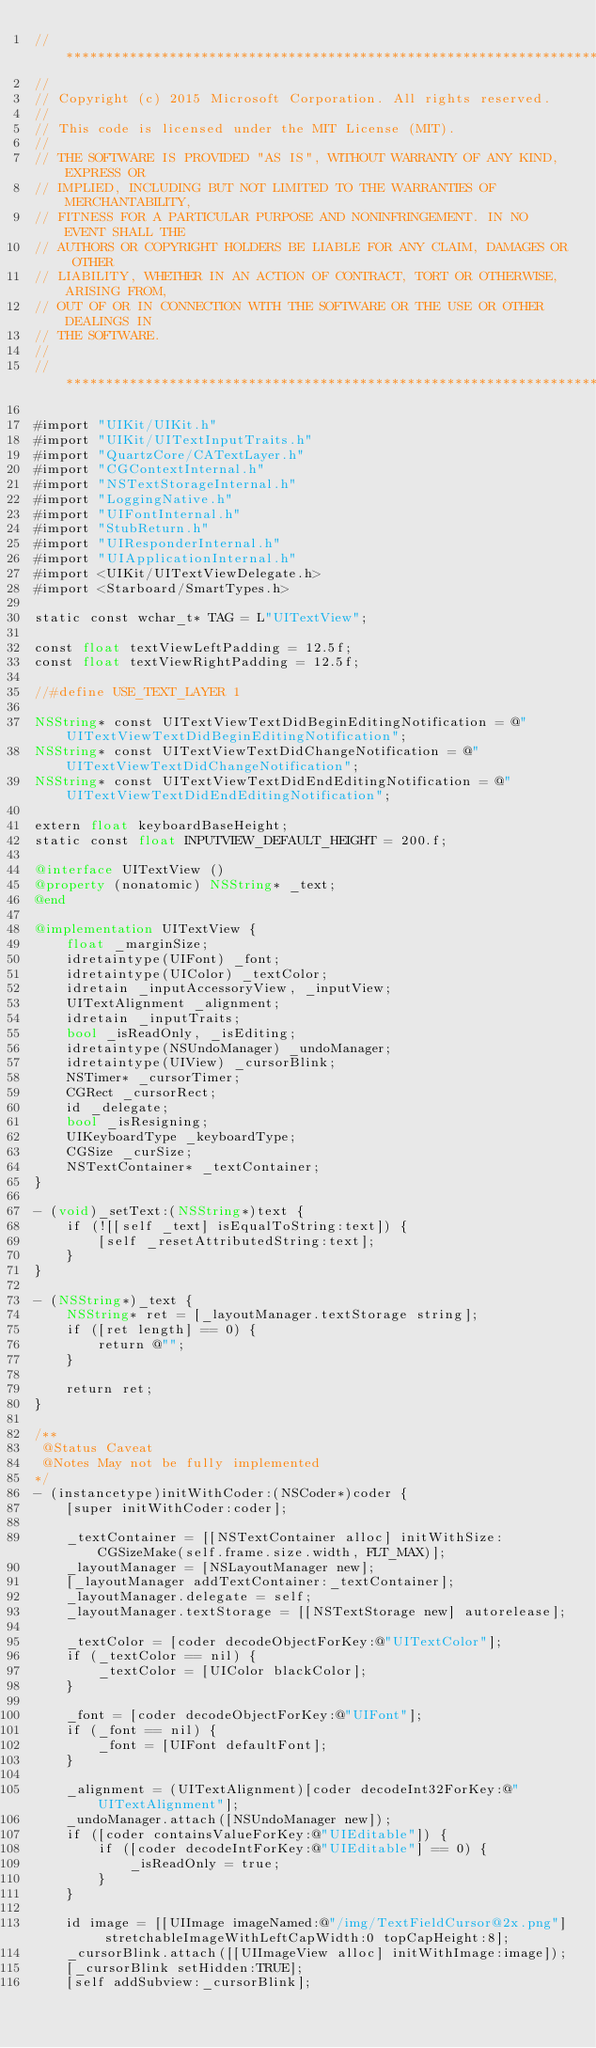<code> <loc_0><loc_0><loc_500><loc_500><_ObjectiveC_>//******************************************************************************
//
// Copyright (c) 2015 Microsoft Corporation. All rights reserved.
//
// This code is licensed under the MIT License (MIT).
//
// THE SOFTWARE IS PROVIDED "AS IS", WITHOUT WARRANTY OF ANY KIND, EXPRESS OR
// IMPLIED, INCLUDING BUT NOT LIMITED TO THE WARRANTIES OF MERCHANTABILITY,
// FITNESS FOR A PARTICULAR PURPOSE AND NONINFRINGEMENT. IN NO EVENT SHALL THE
// AUTHORS OR COPYRIGHT HOLDERS BE LIABLE FOR ANY CLAIM, DAMAGES OR OTHER
// LIABILITY, WHETHER IN AN ACTION OF CONTRACT, TORT OR OTHERWISE, ARISING FROM,
// OUT OF OR IN CONNECTION WITH THE SOFTWARE OR THE USE OR OTHER DEALINGS IN
// THE SOFTWARE.
//
//******************************************************************************

#import "UIKit/UIKit.h"
#import "UIKit/UITextInputTraits.h"
#import "QuartzCore/CATextLayer.h"
#import "CGContextInternal.h"
#import "NSTextStorageInternal.h"
#import "LoggingNative.h"
#import "UIFontInternal.h"
#import "StubReturn.h"
#import "UIResponderInternal.h"
#import "UIApplicationInternal.h"
#import <UIKit/UITextViewDelegate.h>
#import <Starboard/SmartTypes.h>

static const wchar_t* TAG = L"UITextView";

const float textViewLeftPadding = 12.5f;
const float textViewRightPadding = 12.5f;

//#define USE_TEXT_LAYER 1

NSString* const UITextViewTextDidBeginEditingNotification = @"UITextViewTextDidBeginEditingNotification";
NSString* const UITextViewTextDidChangeNotification = @"UITextViewTextDidChangeNotification";
NSString* const UITextViewTextDidEndEditingNotification = @"UITextViewTextDidEndEditingNotification";

extern float keyboardBaseHeight;
static const float INPUTVIEW_DEFAULT_HEIGHT = 200.f;

@interface UITextView ()
@property (nonatomic) NSString* _text;
@end

@implementation UITextView {
    float _marginSize;
    idretaintype(UIFont) _font;
    idretaintype(UIColor) _textColor;
    idretain _inputAccessoryView, _inputView;
    UITextAlignment _alignment;
    idretain _inputTraits;
    bool _isReadOnly, _isEditing;
    idretaintype(NSUndoManager) _undoManager;
    idretaintype(UIView) _cursorBlink;
    NSTimer* _cursorTimer;
    CGRect _cursorRect;
    id _delegate;
    bool _isResigning;
    UIKeyboardType _keyboardType;
    CGSize _curSize;
    NSTextContainer* _textContainer;
}

- (void)_setText:(NSString*)text {
    if (![[self _text] isEqualToString:text]) {
        [self _resetAttributedString:text];
    }
}

- (NSString*)_text {
    NSString* ret = [_layoutManager.textStorage string];
    if ([ret length] == 0) {
        return @"";
    }

    return ret;
}

/**
 @Status Caveat
 @Notes May not be fully implemented
*/
- (instancetype)initWithCoder:(NSCoder*)coder {
    [super initWithCoder:coder];

    _textContainer = [[NSTextContainer alloc] initWithSize:CGSizeMake(self.frame.size.width, FLT_MAX)];
    _layoutManager = [NSLayoutManager new];
    [_layoutManager addTextContainer:_textContainer];
    _layoutManager.delegate = self;
    _layoutManager.textStorage = [[NSTextStorage new] autorelease];

    _textColor = [coder decodeObjectForKey:@"UITextColor"];
    if (_textColor == nil) {
        _textColor = [UIColor blackColor];
    }

    _font = [coder decodeObjectForKey:@"UIFont"];
    if (_font == nil) {
        _font = [UIFont defaultFont];
    }

    _alignment = (UITextAlignment)[coder decodeInt32ForKey:@"UITextAlignment"];
    _undoManager.attach([NSUndoManager new]);
    if ([coder containsValueForKey:@"UIEditable"]) {
        if ([coder decodeIntForKey:@"UIEditable"] == 0) {
            _isReadOnly = true;
        }
    }

    id image = [[UIImage imageNamed:@"/img/TextFieldCursor@2x.png"] stretchableImageWithLeftCapWidth:0 topCapHeight:8];
    _cursorBlink.attach([[UIImageView alloc] initWithImage:image]);
    [_cursorBlink setHidden:TRUE];
    [self addSubview:_cursorBlink];</code> 